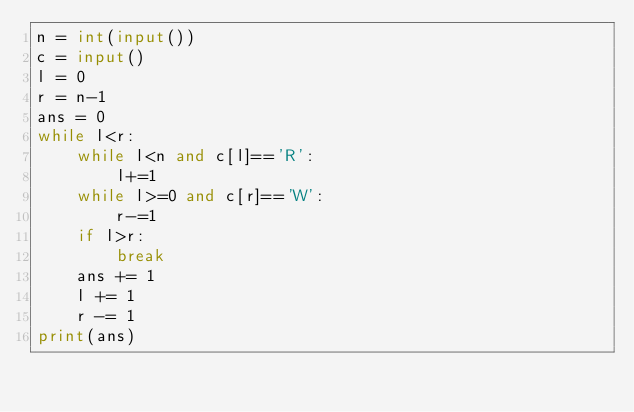<code> <loc_0><loc_0><loc_500><loc_500><_Python_>n = int(input())
c = input()
l = 0
r = n-1
ans = 0
while l<r:
    while l<n and c[l]=='R':
        l+=1
    while l>=0 and c[r]=='W':
        r-=1
    if l>r:
        break
    ans += 1
    l += 1
    r -= 1
print(ans)</code> 